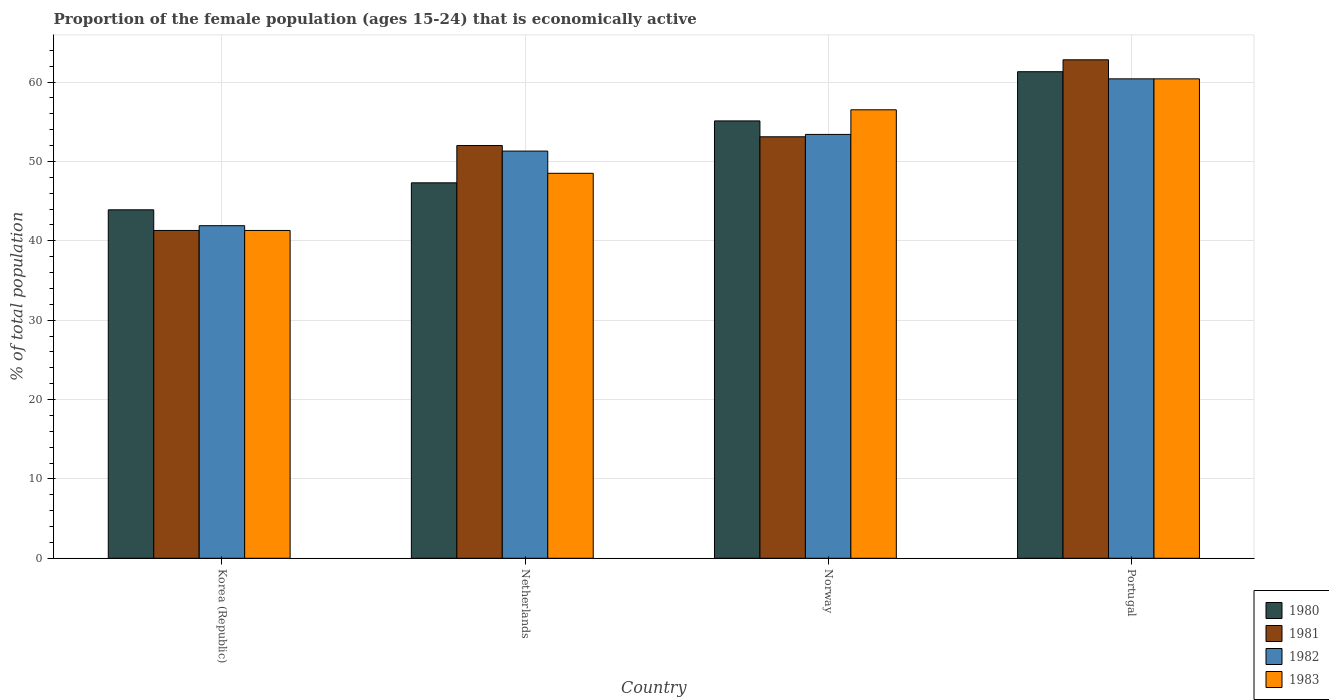How many different coloured bars are there?
Provide a succinct answer. 4. How many groups of bars are there?
Offer a terse response. 4. How many bars are there on the 3rd tick from the left?
Give a very brief answer. 4. How many bars are there on the 3rd tick from the right?
Give a very brief answer. 4. What is the label of the 3rd group of bars from the left?
Offer a terse response. Norway. What is the proportion of the female population that is economically active in 1983 in Netherlands?
Your response must be concise. 48.5. Across all countries, what is the maximum proportion of the female population that is economically active in 1981?
Offer a very short reply. 62.8. Across all countries, what is the minimum proportion of the female population that is economically active in 1980?
Offer a very short reply. 43.9. In which country was the proportion of the female population that is economically active in 1981 minimum?
Your answer should be very brief. Korea (Republic). What is the total proportion of the female population that is economically active in 1980 in the graph?
Offer a terse response. 207.6. What is the difference between the proportion of the female population that is economically active in 1983 in Korea (Republic) and that in Portugal?
Your response must be concise. -19.1. What is the difference between the proportion of the female population that is economically active in 1983 in Portugal and the proportion of the female population that is economically active in 1981 in Netherlands?
Provide a succinct answer. 8.4. What is the average proportion of the female population that is economically active in 1981 per country?
Offer a terse response. 52.3. In how many countries, is the proportion of the female population that is economically active in 1981 greater than 14 %?
Your answer should be compact. 4. What is the ratio of the proportion of the female population that is economically active in 1980 in Korea (Republic) to that in Portugal?
Keep it short and to the point. 0.72. Is the proportion of the female population that is economically active in 1980 in Korea (Republic) less than that in Portugal?
Provide a succinct answer. Yes. Is the difference between the proportion of the female population that is economically active in 1980 in Korea (Republic) and Norway greater than the difference between the proportion of the female population that is economically active in 1982 in Korea (Republic) and Norway?
Offer a terse response. Yes. In how many countries, is the proportion of the female population that is economically active in 1980 greater than the average proportion of the female population that is economically active in 1980 taken over all countries?
Keep it short and to the point. 2. Is the sum of the proportion of the female population that is economically active in 1981 in Netherlands and Norway greater than the maximum proportion of the female population that is economically active in 1980 across all countries?
Your answer should be compact. Yes. What does the 4th bar from the right in Norway represents?
Give a very brief answer. 1980. How many bars are there?
Make the answer very short. 16. Are all the bars in the graph horizontal?
Offer a terse response. No. What is the difference between two consecutive major ticks on the Y-axis?
Keep it short and to the point. 10. Does the graph contain any zero values?
Provide a succinct answer. No. Where does the legend appear in the graph?
Offer a very short reply. Bottom right. How many legend labels are there?
Provide a succinct answer. 4. What is the title of the graph?
Give a very brief answer. Proportion of the female population (ages 15-24) that is economically active. Does "1972" appear as one of the legend labels in the graph?
Ensure brevity in your answer.  No. What is the label or title of the X-axis?
Your response must be concise. Country. What is the label or title of the Y-axis?
Offer a terse response. % of total population. What is the % of total population in 1980 in Korea (Republic)?
Provide a short and direct response. 43.9. What is the % of total population of 1981 in Korea (Republic)?
Your answer should be very brief. 41.3. What is the % of total population in 1982 in Korea (Republic)?
Your answer should be very brief. 41.9. What is the % of total population of 1983 in Korea (Republic)?
Your answer should be compact. 41.3. What is the % of total population of 1980 in Netherlands?
Offer a very short reply. 47.3. What is the % of total population of 1982 in Netherlands?
Your response must be concise. 51.3. What is the % of total population of 1983 in Netherlands?
Keep it short and to the point. 48.5. What is the % of total population in 1980 in Norway?
Ensure brevity in your answer.  55.1. What is the % of total population in 1981 in Norway?
Keep it short and to the point. 53.1. What is the % of total population of 1982 in Norway?
Give a very brief answer. 53.4. What is the % of total population of 1983 in Norway?
Give a very brief answer. 56.5. What is the % of total population of 1980 in Portugal?
Offer a very short reply. 61.3. What is the % of total population in 1981 in Portugal?
Your answer should be compact. 62.8. What is the % of total population in 1982 in Portugal?
Keep it short and to the point. 60.4. What is the % of total population of 1983 in Portugal?
Make the answer very short. 60.4. Across all countries, what is the maximum % of total population of 1980?
Your answer should be very brief. 61.3. Across all countries, what is the maximum % of total population in 1981?
Your answer should be compact. 62.8. Across all countries, what is the maximum % of total population of 1982?
Give a very brief answer. 60.4. Across all countries, what is the maximum % of total population in 1983?
Your answer should be very brief. 60.4. Across all countries, what is the minimum % of total population in 1980?
Your answer should be very brief. 43.9. Across all countries, what is the minimum % of total population of 1981?
Offer a terse response. 41.3. Across all countries, what is the minimum % of total population of 1982?
Ensure brevity in your answer.  41.9. Across all countries, what is the minimum % of total population in 1983?
Your response must be concise. 41.3. What is the total % of total population in 1980 in the graph?
Your answer should be very brief. 207.6. What is the total % of total population in 1981 in the graph?
Your response must be concise. 209.2. What is the total % of total population of 1982 in the graph?
Your answer should be very brief. 207. What is the total % of total population of 1983 in the graph?
Make the answer very short. 206.7. What is the difference between the % of total population in 1981 in Korea (Republic) and that in Netherlands?
Your answer should be very brief. -10.7. What is the difference between the % of total population of 1983 in Korea (Republic) and that in Netherlands?
Your response must be concise. -7.2. What is the difference between the % of total population in 1980 in Korea (Republic) and that in Norway?
Your answer should be compact. -11.2. What is the difference between the % of total population in 1981 in Korea (Republic) and that in Norway?
Your answer should be compact. -11.8. What is the difference between the % of total population in 1982 in Korea (Republic) and that in Norway?
Ensure brevity in your answer.  -11.5. What is the difference between the % of total population in 1983 in Korea (Republic) and that in Norway?
Offer a terse response. -15.2. What is the difference between the % of total population in 1980 in Korea (Republic) and that in Portugal?
Offer a terse response. -17.4. What is the difference between the % of total population in 1981 in Korea (Republic) and that in Portugal?
Make the answer very short. -21.5. What is the difference between the % of total population in 1982 in Korea (Republic) and that in Portugal?
Ensure brevity in your answer.  -18.5. What is the difference between the % of total population in 1983 in Korea (Republic) and that in Portugal?
Provide a short and direct response. -19.1. What is the difference between the % of total population of 1980 in Netherlands and that in Norway?
Your answer should be compact. -7.8. What is the difference between the % of total population of 1982 in Netherlands and that in Norway?
Your answer should be very brief. -2.1. What is the difference between the % of total population in 1981 in Netherlands and that in Portugal?
Keep it short and to the point. -10.8. What is the difference between the % of total population in 1982 in Netherlands and that in Portugal?
Your answer should be very brief. -9.1. What is the difference between the % of total population in 1983 in Netherlands and that in Portugal?
Offer a terse response. -11.9. What is the difference between the % of total population of 1980 in Norway and that in Portugal?
Make the answer very short. -6.2. What is the difference between the % of total population of 1982 in Norway and that in Portugal?
Offer a terse response. -7. What is the difference between the % of total population in 1983 in Norway and that in Portugal?
Provide a short and direct response. -3.9. What is the difference between the % of total population of 1980 in Korea (Republic) and the % of total population of 1982 in Netherlands?
Your answer should be very brief. -7.4. What is the difference between the % of total population in 1980 in Korea (Republic) and the % of total population in 1983 in Netherlands?
Your response must be concise. -4.6. What is the difference between the % of total population of 1981 in Korea (Republic) and the % of total population of 1982 in Netherlands?
Your response must be concise. -10. What is the difference between the % of total population of 1982 in Korea (Republic) and the % of total population of 1983 in Netherlands?
Your answer should be compact. -6.6. What is the difference between the % of total population in 1980 in Korea (Republic) and the % of total population in 1982 in Norway?
Your response must be concise. -9.5. What is the difference between the % of total population of 1981 in Korea (Republic) and the % of total population of 1983 in Norway?
Make the answer very short. -15.2. What is the difference between the % of total population in 1982 in Korea (Republic) and the % of total population in 1983 in Norway?
Provide a short and direct response. -14.6. What is the difference between the % of total population of 1980 in Korea (Republic) and the % of total population of 1981 in Portugal?
Provide a succinct answer. -18.9. What is the difference between the % of total population in 1980 in Korea (Republic) and the % of total population in 1982 in Portugal?
Your answer should be compact. -16.5. What is the difference between the % of total population in 1980 in Korea (Republic) and the % of total population in 1983 in Portugal?
Ensure brevity in your answer.  -16.5. What is the difference between the % of total population in 1981 in Korea (Republic) and the % of total population in 1982 in Portugal?
Offer a very short reply. -19.1. What is the difference between the % of total population of 1981 in Korea (Republic) and the % of total population of 1983 in Portugal?
Offer a very short reply. -19.1. What is the difference between the % of total population in 1982 in Korea (Republic) and the % of total population in 1983 in Portugal?
Your answer should be compact. -18.5. What is the difference between the % of total population of 1980 in Netherlands and the % of total population of 1981 in Norway?
Your answer should be very brief. -5.8. What is the difference between the % of total population of 1980 in Netherlands and the % of total population of 1983 in Norway?
Ensure brevity in your answer.  -9.2. What is the difference between the % of total population of 1982 in Netherlands and the % of total population of 1983 in Norway?
Offer a very short reply. -5.2. What is the difference between the % of total population of 1980 in Netherlands and the % of total population of 1981 in Portugal?
Your answer should be very brief. -15.5. What is the difference between the % of total population in 1980 in Netherlands and the % of total population in 1982 in Portugal?
Provide a succinct answer. -13.1. What is the difference between the % of total population of 1981 in Netherlands and the % of total population of 1982 in Portugal?
Provide a succinct answer. -8.4. What is the difference between the % of total population in 1981 in Netherlands and the % of total population in 1983 in Portugal?
Offer a very short reply. -8.4. What is the difference between the % of total population in 1982 in Netherlands and the % of total population in 1983 in Portugal?
Provide a succinct answer. -9.1. What is the difference between the % of total population of 1980 in Norway and the % of total population of 1982 in Portugal?
Make the answer very short. -5.3. What is the difference between the % of total population of 1980 in Norway and the % of total population of 1983 in Portugal?
Your response must be concise. -5.3. What is the difference between the % of total population of 1982 in Norway and the % of total population of 1983 in Portugal?
Make the answer very short. -7. What is the average % of total population in 1980 per country?
Offer a very short reply. 51.9. What is the average % of total population of 1981 per country?
Give a very brief answer. 52.3. What is the average % of total population in 1982 per country?
Provide a short and direct response. 51.75. What is the average % of total population of 1983 per country?
Provide a succinct answer. 51.67. What is the difference between the % of total population in 1980 and % of total population in 1981 in Korea (Republic)?
Give a very brief answer. 2.6. What is the difference between the % of total population of 1980 and % of total population of 1983 in Korea (Republic)?
Keep it short and to the point. 2.6. What is the difference between the % of total population of 1981 and % of total population of 1982 in Korea (Republic)?
Your answer should be compact. -0.6. What is the difference between the % of total population in 1980 and % of total population in 1981 in Netherlands?
Give a very brief answer. -4.7. What is the difference between the % of total population of 1980 and % of total population of 1983 in Netherlands?
Your answer should be very brief. -1.2. What is the difference between the % of total population in 1981 and % of total population in 1982 in Netherlands?
Offer a very short reply. 0.7. What is the difference between the % of total population of 1982 and % of total population of 1983 in Netherlands?
Your answer should be very brief. 2.8. What is the difference between the % of total population of 1980 and % of total population of 1981 in Norway?
Your answer should be compact. 2. What is the difference between the % of total population of 1980 and % of total population of 1983 in Norway?
Keep it short and to the point. -1.4. What is the difference between the % of total population of 1980 and % of total population of 1982 in Portugal?
Your response must be concise. 0.9. What is the difference between the % of total population in 1980 and % of total population in 1983 in Portugal?
Your answer should be compact. 0.9. What is the ratio of the % of total population of 1980 in Korea (Republic) to that in Netherlands?
Give a very brief answer. 0.93. What is the ratio of the % of total population in 1981 in Korea (Republic) to that in Netherlands?
Provide a short and direct response. 0.79. What is the ratio of the % of total population of 1982 in Korea (Republic) to that in Netherlands?
Provide a succinct answer. 0.82. What is the ratio of the % of total population of 1983 in Korea (Republic) to that in Netherlands?
Your answer should be compact. 0.85. What is the ratio of the % of total population in 1980 in Korea (Republic) to that in Norway?
Offer a very short reply. 0.8. What is the ratio of the % of total population in 1982 in Korea (Republic) to that in Norway?
Provide a short and direct response. 0.78. What is the ratio of the % of total population of 1983 in Korea (Republic) to that in Norway?
Give a very brief answer. 0.73. What is the ratio of the % of total population in 1980 in Korea (Republic) to that in Portugal?
Provide a succinct answer. 0.72. What is the ratio of the % of total population in 1981 in Korea (Republic) to that in Portugal?
Make the answer very short. 0.66. What is the ratio of the % of total population of 1982 in Korea (Republic) to that in Portugal?
Offer a terse response. 0.69. What is the ratio of the % of total population in 1983 in Korea (Republic) to that in Portugal?
Offer a very short reply. 0.68. What is the ratio of the % of total population of 1980 in Netherlands to that in Norway?
Ensure brevity in your answer.  0.86. What is the ratio of the % of total population of 1981 in Netherlands to that in Norway?
Give a very brief answer. 0.98. What is the ratio of the % of total population of 1982 in Netherlands to that in Norway?
Your response must be concise. 0.96. What is the ratio of the % of total population of 1983 in Netherlands to that in Norway?
Your answer should be compact. 0.86. What is the ratio of the % of total population of 1980 in Netherlands to that in Portugal?
Ensure brevity in your answer.  0.77. What is the ratio of the % of total population in 1981 in Netherlands to that in Portugal?
Your answer should be compact. 0.83. What is the ratio of the % of total population in 1982 in Netherlands to that in Portugal?
Offer a terse response. 0.85. What is the ratio of the % of total population in 1983 in Netherlands to that in Portugal?
Provide a short and direct response. 0.8. What is the ratio of the % of total population of 1980 in Norway to that in Portugal?
Your response must be concise. 0.9. What is the ratio of the % of total population in 1981 in Norway to that in Portugal?
Your answer should be very brief. 0.85. What is the ratio of the % of total population in 1982 in Norway to that in Portugal?
Your response must be concise. 0.88. What is the ratio of the % of total population of 1983 in Norway to that in Portugal?
Provide a short and direct response. 0.94. What is the difference between the highest and the second highest % of total population of 1980?
Your answer should be very brief. 6.2. What is the difference between the highest and the second highest % of total population of 1981?
Provide a succinct answer. 9.7. What is the difference between the highest and the second highest % of total population in 1982?
Your answer should be very brief. 7. What is the difference between the highest and the second highest % of total population in 1983?
Provide a short and direct response. 3.9. What is the difference between the highest and the lowest % of total population in 1980?
Make the answer very short. 17.4. 